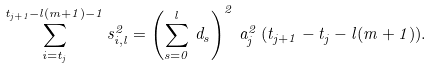Convert formula to latex. <formula><loc_0><loc_0><loc_500><loc_500>\sum _ { i = t _ { j } } ^ { t _ { j + 1 } - l ( m + 1 ) - 1 } s _ { i , l } ^ { 2 } = \left ( \sum _ { s = 0 } ^ { l } \, d _ { s } \right ) ^ { 2 } \, a _ { j } ^ { 2 } \, ( t _ { j + 1 } - t _ { j } - l ( m + 1 ) ) .</formula> 